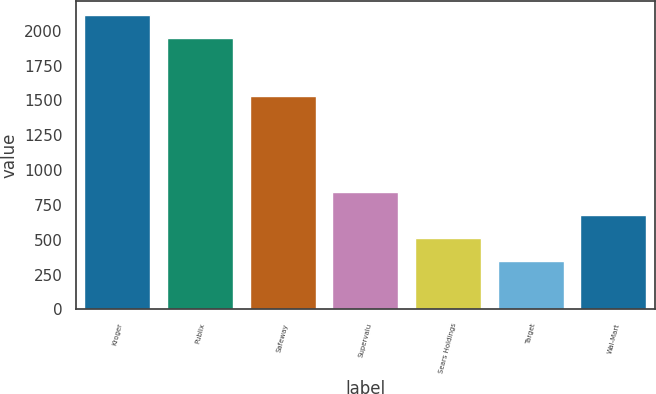Convert chart. <chart><loc_0><loc_0><loc_500><loc_500><bar_chart><fcel>Kroger<fcel>Publix<fcel>Safeway<fcel>Supervalu<fcel>Sears Holdings<fcel>Target<fcel>Wal-Mart<nl><fcel>2111.7<fcel>1948<fcel>1535<fcel>841.1<fcel>513.7<fcel>350<fcel>677.4<nl></chart> 